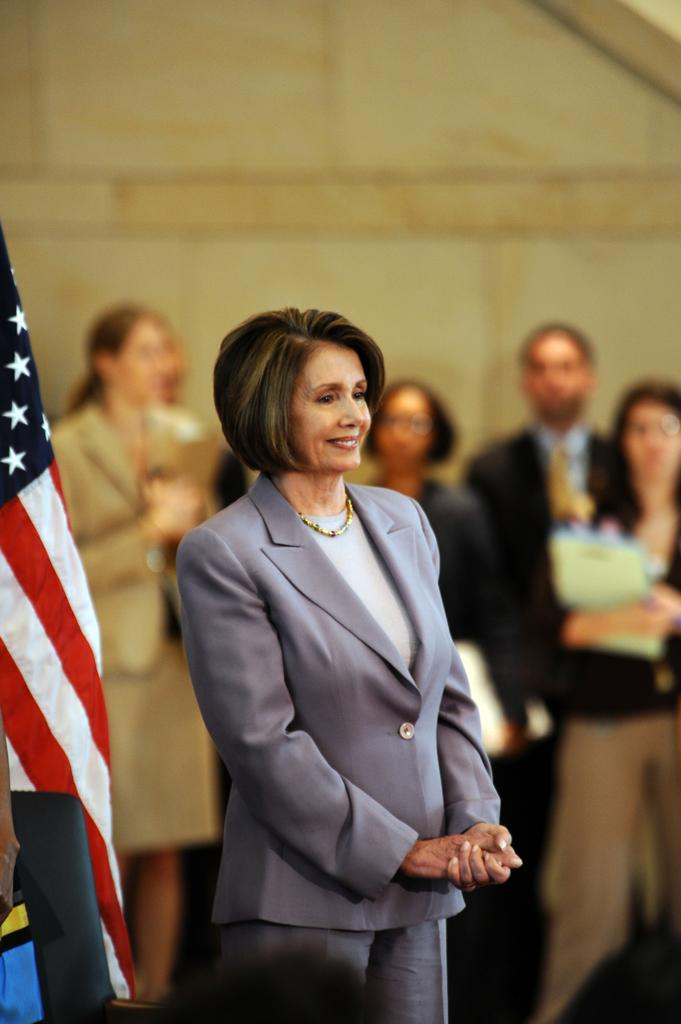What is located in the left corner of the image? There is a flag in the left corner of the image. What can be seen in the foreground of the image? There is a person standing in the foreground. How many people are present in the image? There are people standing in the image. What is visible in the background of the image? There appears to be a wall in the background of the image. Where is the sink located in the image? There is no sink present in the image. What type of crib can be seen in the image? There is no crib present in the image. 